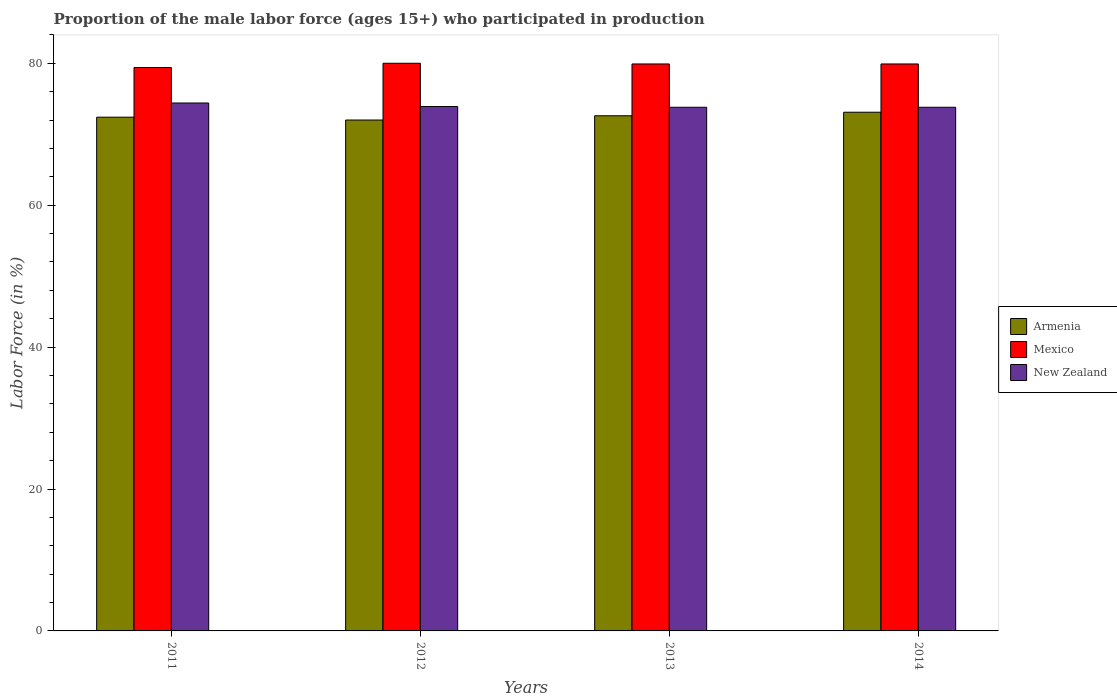How many groups of bars are there?
Your answer should be very brief. 4. How many bars are there on the 2nd tick from the left?
Ensure brevity in your answer.  3. What is the label of the 2nd group of bars from the left?
Make the answer very short. 2012. What is the proportion of the male labor force who participated in production in Armenia in 2014?
Provide a short and direct response. 73.1. Across all years, what is the maximum proportion of the male labor force who participated in production in Mexico?
Provide a succinct answer. 80. Across all years, what is the minimum proportion of the male labor force who participated in production in Mexico?
Offer a very short reply. 79.4. In which year was the proportion of the male labor force who participated in production in Mexico minimum?
Your answer should be compact. 2011. What is the total proportion of the male labor force who participated in production in Armenia in the graph?
Provide a succinct answer. 290.1. What is the difference between the proportion of the male labor force who participated in production in Mexico in 2011 and that in 2012?
Your response must be concise. -0.6. What is the difference between the proportion of the male labor force who participated in production in Mexico in 2012 and the proportion of the male labor force who participated in production in Armenia in 2013?
Offer a terse response. 7.4. What is the average proportion of the male labor force who participated in production in Armenia per year?
Ensure brevity in your answer.  72.52. In the year 2012, what is the difference between the proportion of the male labor force who participated in production in New Zealand and proportion of the male labor force who participated in production in Armenia?
Ensure brevity in your answer.  1.9. What is the ratio of the proportion of the male labor force who participated in production in Armenia in 2012 to that in 2013?
Keep it short and to the point. 0.99. Is the proportion of the male labor force who participated in production in Mexico in 2012 less than that in 2014?
Make the answer very short. No. What is the difference between the highest and the lowest proportion of the male labor force who participated in production in New Zealand?
Ensure brevity in your answer.  0.6. Is the sum of the proportion of the male labor force who participated in production in Mexico in 2012 and 2013 greater than the maximum proportion of the male labor force who participated in production in Armenia across all years?
Your answer should be very brief. Yes. What does the 2nd bar from the left in 2012 represents?
Offer a terse response. Mexico. What does the 2nd bar from the right in 2013 represents?
Offer a terse response. Mexico. Is it the case that in every year, the sum of the proportion of the male labor force who participated in production in Mexico and proportion of the male labor force who participated in production in Armenia is greater than the proportion of the male labor force who participated in production in New Zealand?
Provide a short and direct response. Yes. How many bars are there?
Provide a succinct answer. 12. Are all the bars in the graph horizontal?
Your answer should be compact. No. How many years are there in the graph?
Keep it short and to the point. 4. What is the difference between two consecutive major ticks on the Y-axis?
Ensure brevity in your answer.  20. Are the values on the major ticks of Y-axis written in scientific E-notation?
Make the answer very short. No. Where does the legend appear in the graph?
Give a very brief answer. Center right. How are the legend labels stacked?
Your response must be concise. Vertical. What is the title of the graph?
Give a very brief answer. Proportion of the male labor force (ages 15+) who participated in production. What is the label or title of the Y-axis?
Provide a short and direct response. Labor Force (in %). What is the Labor Force (in %) of Armenia in 2011?
Keep it short and to the point. 72.4. What is the Labor Force (in %) in Mexico in 2011?
Your response must be concise. 79.4. What is the Labor Force (in %) in New Zealand in 2011?
Offer a very short reply. 74.4. What is the Labor Force (in %) of New Zealand in 2012?
Your answer should be very brief. 73.9. What is the Labor Force (in %) in Armenia in 2013?
Your answer should be very brief. 72.6. What is the Labor Force (in %) in Mexico in 2013?
Offer a very short reply. 79.9. What is the Labor Force (in %) in New Zealand in 2013?
Your answer should be very brief. 73.8. What is the Labor Force (in %) in Armenia in 2014?
Give a very brief answer. 73.1. What is the Labor Force (in %) in Mexico in 2014?
Your answer should be very brief. 79.9. What is the Labor Force (in %) of New Zealand in 2014?
Provide a short and direct response. 73.8. Across all years, what is the maximum Labor Force (in %) in Armenia?
Offer a very short reply. 73.1. Across all years, what is the maximum Labor Force (in %) of Mexico?
Keep it short and to the point. 80. Across all years, what is the maximum Labor Force (in %) in New Zealand?
Ensure brevity in your answer.  74.4. Across all years, what is the minimum Labor Force (in %) of Armenia?
Give a very brief answer. 72. Across all years, what is the minimum Labor Force (in %) of Mexico?
Your response must be concise. 79.4. Across all years, what is the minimum Labor Force (in %) of New Zealand?
Give a very brief answer. 73.8. What is the total Labor Force (in %) of Armenia in the graph?
Offer a terse response. 290.1. What is the total Labor Force (in %) of Mexico in the graph?
Ensure brevity in your answer.  319.2. What is the total Labor Force (in %) of New Zealand in the graph?
Provide a succinct answer. 295.9. What is the difference between the Labor Force (in %) in New Zealand in 2011 and that in 2012?
Your response must be concise. 0.5. What is the difference between the Labor Force (in %) in Mexico in 2011 and that in 2013?
Your response must be concise. -0.5. What is the difference between the Labor Force (in %) in New Zealand in 2011 and that in 2013?
Your answer should be very brief. 0.6. What is the difference between the Labor Force (in %) in Mexico in 2011 and that in 2014?
Keep it short and to the point. -0.5. What is the difference between the Labor Force (in %) in New Zealand in 2011 and that in 2014?
Give a very brief answer. 0.6. What is the difference between the Labor Force (in %) of Mexico in 2013 and that in 2014?
Give a very brief answer. 0. What is the difference between the Labor Force (in %) in New Zealand in 2013 and that in 2014?
Give a very brief answer. 0. What is the difference between the Labor Force (in %) in Mexico in 2011 and the Labor Force (in %) in New Zealand in 2012?
Make the answer very short. 5.5. What is the difference between the Labor Force (in %) in Armenia in 2011 and the Labor Force (in %) in New Zealand in 2013?
Provide a succinct answer. -1.4. What is the difference between the Labor Force (in %) of Armenia in 2011 and the Labor Force (in %) of Mexico in 2014?
Offer a very short reply. -7.5. What is the difference between the Labor Force (in %) of Armenia in 2011 and the Labor Force (in %) of New Zealand in 2014?
Your answer should be very brief. -1.4. What is the difference between the Labor Force (in %) of Mexico in 2011 and the Labor Force (in %) of New Zealand in 2014?
Ensure brevity in your answer.  5.6. What is the difference between the Labor Force (in %) of Armenia in 2012 and the Labor Force (in %) of Mexico in 2013?
Your response must be concise. -7.9. What is the difference between the Labor Force (in %) in Armenia in 2012 and the Labor Force (in %) in Mexico in 2014?
Provide a succinct answer. -7.9. What is the difference between the Labor Force (in %) in Armenia in 2013 and the Labor Force (in %) in Mexico in 2014?
Your answer should be compact. -7.3. What is the difference between the Labor Force (in %) in Mexico in 2013 and the Labor Force (in %) in New Zealand in 2014?
Provide a short and direct response. 6.1. What is the average Labor Force (in %) of Armenia per year?
Ensure brevity in your answer.  72.53. What is the average Labor Force (in %) in Mexico per year?
Make the answer very short. 79.8. What is the average Labor Force (in %) of New Zealand per year?
Your response must be concise. 73.97. In the year 2011, what is the difference between the Labor Force (in %) of Armenia and Labor Force (in %) of Mexico?
Offer a very short reply. -7. In the year 2011, what is the difference between the Labor Force (in %) of Mexico and Labor Force (in %) of New Zealand?
Provide a short and direct response. 5. In the year 2012, what is the difference between the Labor Force (in %) of Armenia and Labor Force (in %) of New Zealand?
Keep it short and to the point. -1.9. In the year 2012, what is the difference between the Labor Force (in %) of Mexico and Labor Force (in %) of New Zealand?
Give a very brief answer. 6.1. In the year 2013, what is the difference between the Labor Force (in %) in Armenia and Labor Force (in %) in Mexico?
Keep it short and to the point. -7.3. In the year 2013, what is the difference between the Labor Force (in %) of Armenia and Labor Force (in %) of New Zealand?
Your response must be concise. -1.2. In the year 2013, what is the difference between the Labor Force (in %) of Mexico and Labor Force (in %) of New Zealand?
Your answer should be compact. 6.1. In the year 2014, what is the difference between the Labor Force (in %) of Armenia and Labor Force (in %) of Mexico?
Provide a short and direct response. -6.8. What is the ratio of the Labor Force (in %) in Armenia in 2011 to that in 2012?
Offer a very short reply. 1.01. What is the ratio of the Labor Force (in %) in New Zealand in 2011 to that in 2012?
Keep it short and to the point. 1.01. What is the ratio of the Labor Force (in %) of Armenia in 2011 to that in 2013?
Give a very brief answer. 1. What is the ratio of the Labor Force (in %) of Mexico in 2011 to that in 2013?
Give a very brief answer. 0.99. What is the ratio of the Labor Force (in %) of Armenia in 2011 to that in 2014?
Make the answer very short. 0.99. What is the ratio of the Labor Force (in %) in New Zealand in 2011 to that in 2014?
Your answer should be compact. 1.01. What is the ratio of the Labor Force (in %) of New Zealand in 2012 to that in 2013?
Offer a very short reply. 1. What is the ratio of the Labor Force (in %) in Armenia in 2012 to that in 2014?
Your answer should be compact. 0.98. What is the ratio of the Labor Force (in %) in New Zealand in 2012 to that in 2014?
Provide a succinct answer. 1. What is the ratio of the Labor Force (in %) of Armenia in 2013 to that in 2014?
Offer a terse response. 0.99. What is the difference between the highest and the second highest Labor Force (in %) in Armenia?
Offer a very short reply. 0.5. What is the difference between the highest and the lowest Labor Force (in %) in Mexico?
Ensure brevity in your answer.  0.6. What is the difference between the highest and the lowest Labor Force (in %) in New Zealand?
Keep it short and to the point. 0.6. 